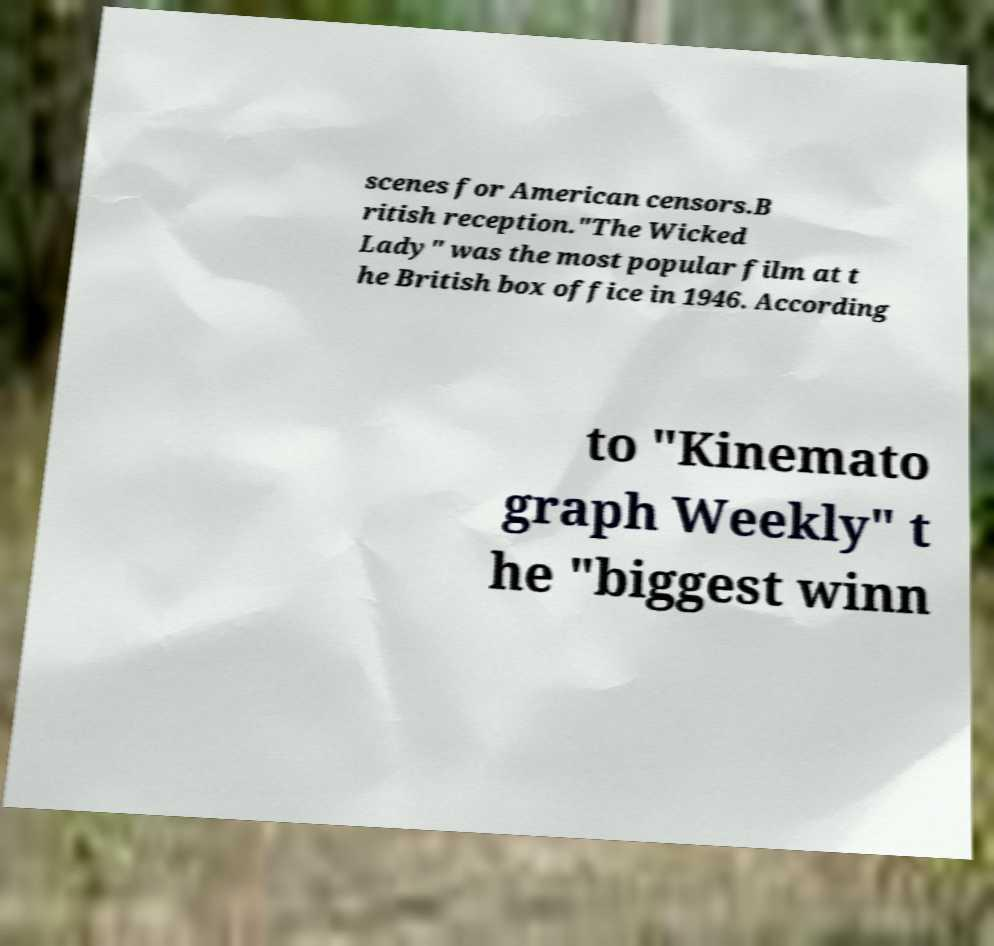For documentation purposes, I need the text within this image transcribed. Could you provide that? scenes for American censors.B ritish reception."The Wicked Lady" was the most popular film at t he British box office in 1946. According to "Kinemato graph Weekly" t he "biggest winn 